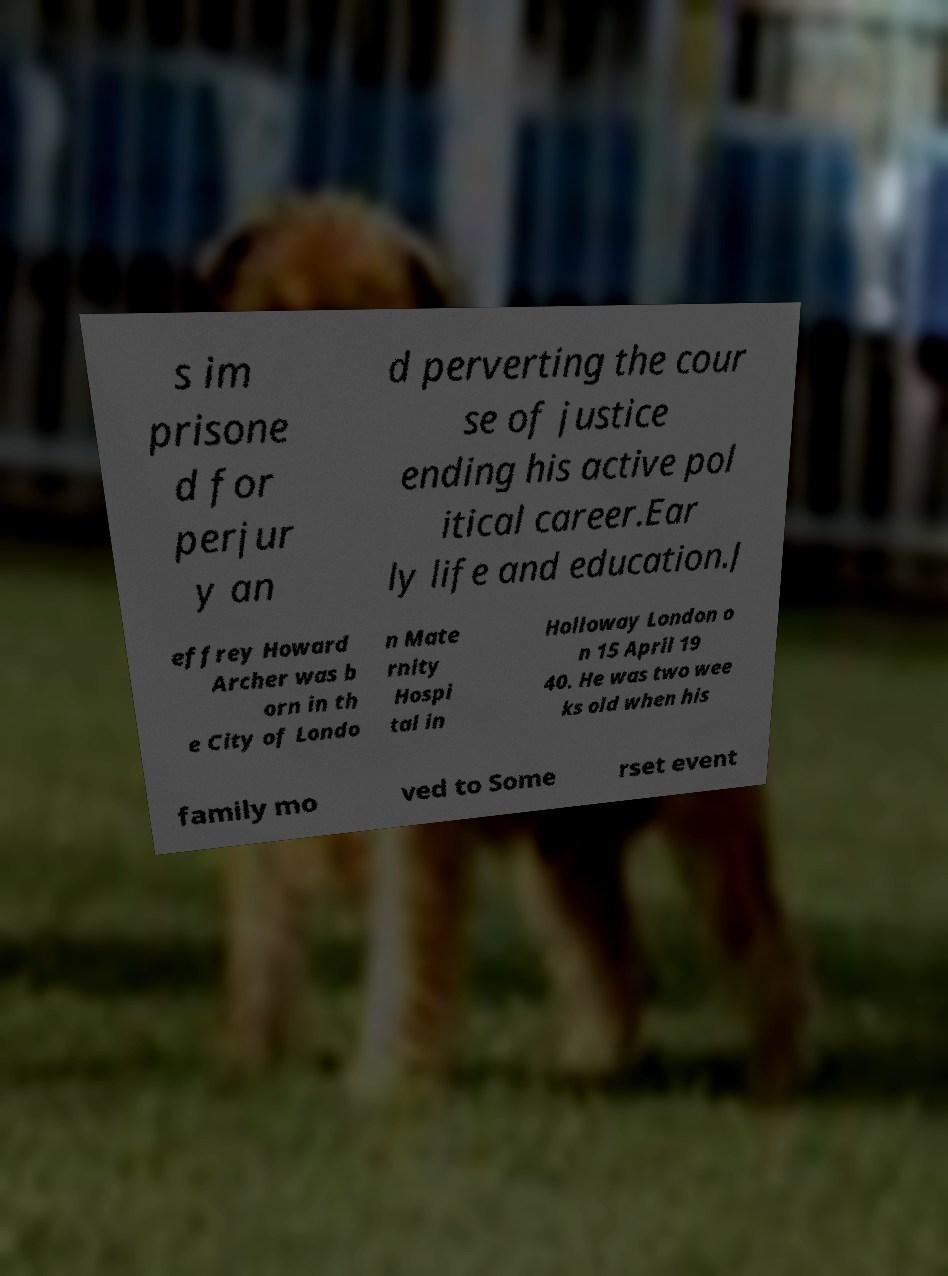What messages or text are displayed in this image? I need them in a readable, typed format. s im prisone d for perjur y an d perverting the cour se of justice ending his active pol itical career.Ear ly life and education.J effrey Howard Archer was b orn in th e City of Londo n Mate rnity Hospi tal in Holloway London o n 15 April 19 40. He was two wee ks old when his family mo ved to Some rset event 